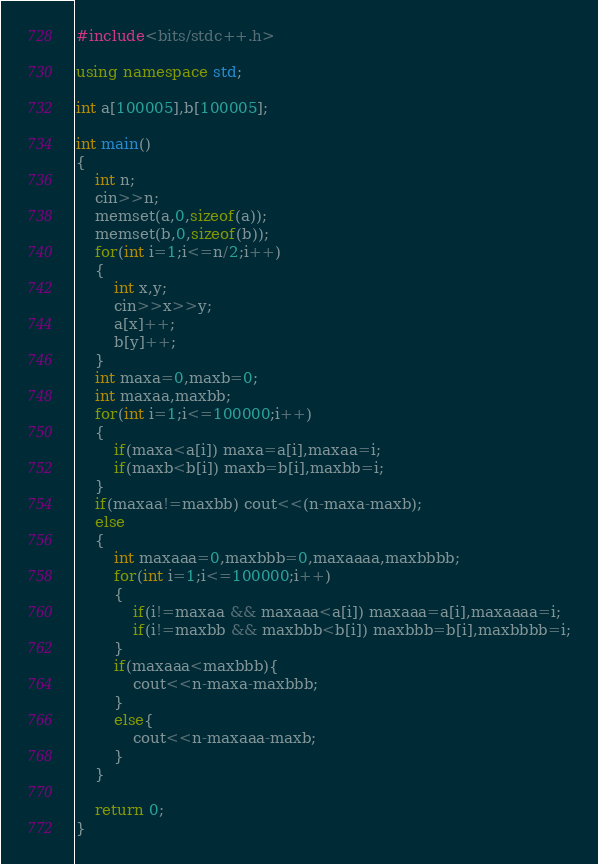Convert code to text. <code><loc_0><loc_0><loc_500><loc_500><_C++_>#include<bits/stdc++.h>

using namespace std;

int a[100005],b[100005];

int main()
{
	int n;
	cin>>n;
	memset(a,0,sizeof(a));
	memset(b,0,sizeof(b));
	for(int i=1;i<=n/2;i++)
	{
		int x,y;
		cin>>x>>y;
		a[x]++;
		b[y]++;
	}
	int maxa=0,maxb=0;
	int maxaa,maxbb;
	for(int i=1;i<=100000;i++)
	{
		if(maxa<a[i]) maxa=a[i],maxaa=i;
		if(maxb<b[i]) maxb=b[i],maxbb=i;
	}
	if(maxaa!=maxbb) cout<<(n-maxa-maxb);
	else
	{
		int maxaaa=0,maxbbb=0,maxaaaa,maxbbbb;
		for(int i=1;i<=100000;i++)
		{
			if(i!=maxaa && maxaaa<a[i]) maxaaa=a[i],maxaaaa=i;
			if(i!=maxbb && maxbbb<b[i]) maxbbb=b[i],maxbbbb=i;
		}
		if(maxaaa<maxbbb){
			cout<<n-maxa-maxbbb;
		}
		else{
			cout<<n-maxaaa-maxb;
		}
	}
	
	return 0;
}
</code> 